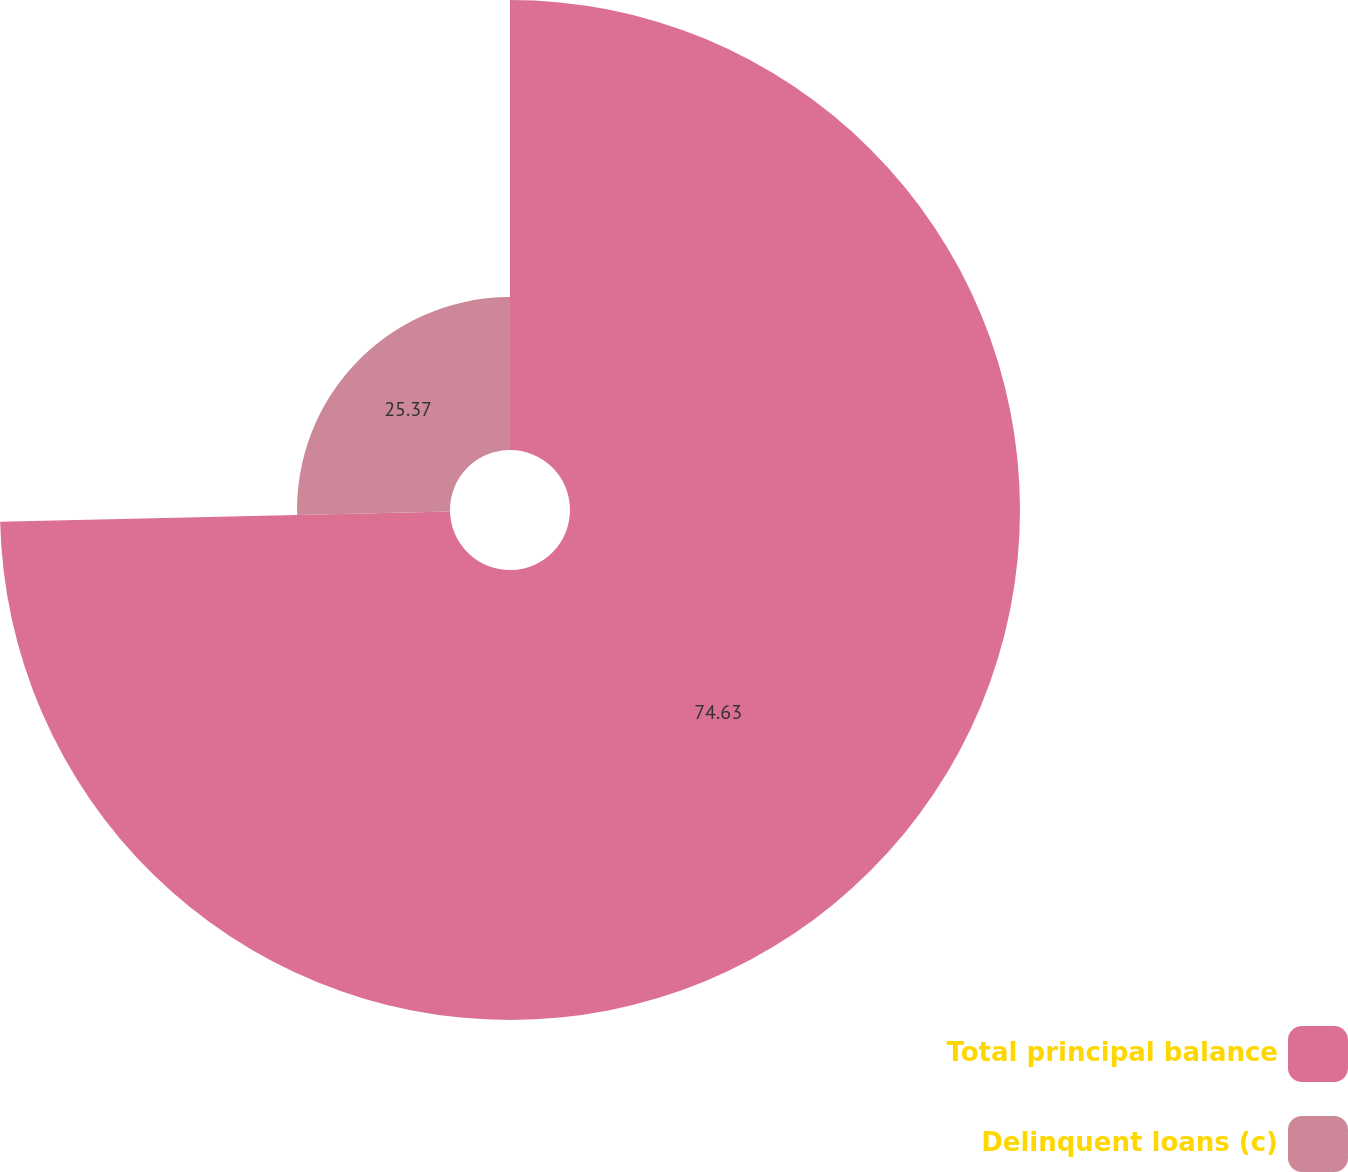Convert chart to OTSL. <chart><loc_0><loc_0><loc_500><loc_500><pie_chart><fcel>Total principal balance<fcel>Delinquent loans (c)<nl><fcel>74.63%<fcel>25.37%<nl></chart> 